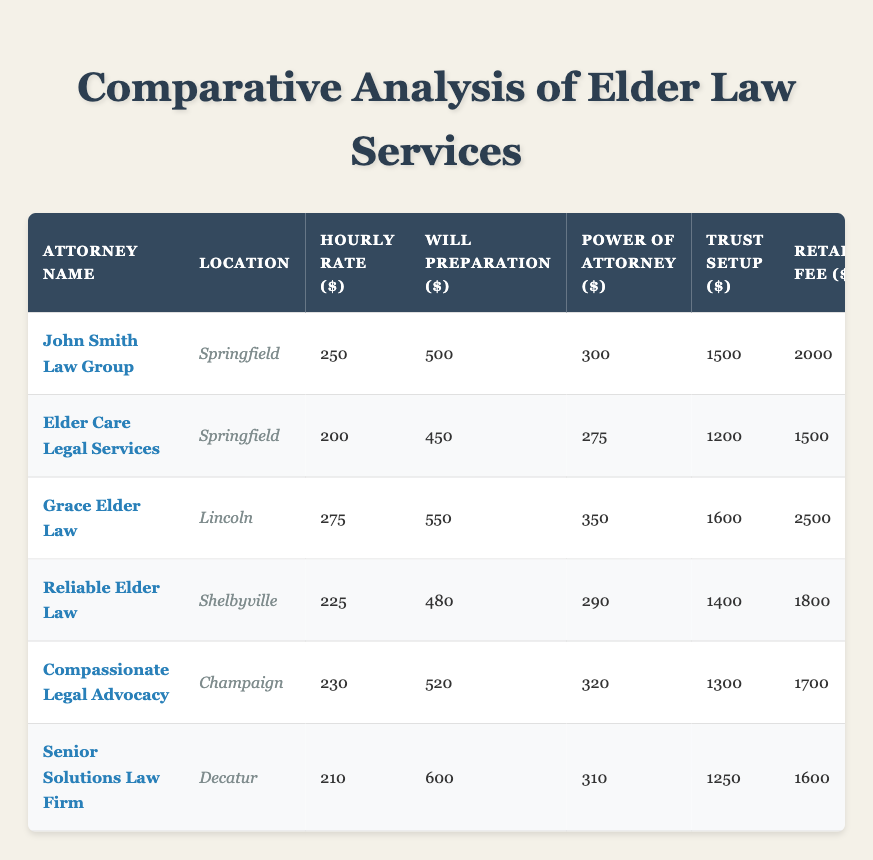What is the highest hourly rate among the attorneys listed? The highest hourly rate is found in the "Hourly Rate ($)" column. Scanning through the rates, John Smith Law Group has the highest rate at $250.
Answer: 250 Which attorney has the lowest consultation fee? The consultation fees can be found in the "Consultation Fee ($)" column. Looking at the values, Senior Solutions Law Firm has the lowest consultation fee at $110.
Answer: 110 How many years of experience does Grace Elder Law have? The years of experience for each attorney are listed in the "Experience (Years)" column. Grace Elder Law has 30 years of experience.
Answer: 30 What is the average flat fee for will preparation among all attorneys? To calculate the average, sum all the flat fee values for will preparation (500 + 450 + 550 + 480 + 520 + 600 = 3080) and divide by the number of attorneys (6), resulting in an average of 3080 / 6 = 513.33.
Answer: 513.33 Is the retainer fee for Compassionate Legal Advocacy higher than that of Elder Care Legal Services? Looking at the "Retainer Fee ($)" column, Compassionate Legal Advocacy has a retainer fee of $1700, and Elder Care Legal Services has $1500. Since $1700 is greater than $1500, the answer is yes.
Answer: Yes What is the difference in the flat fee for trust setup between the highest and lowest values? The highest flat fee for trust setup is Grace Elder Law at $1600, and the lowest is Senior Solutions Law Firm at $1250. The difference is 1600 - 1250 = 350.
Answer: 350 Which attorney has the best client rating and what is their rating? The client ratings are in the "Client Rating" column. Scanning through the ratings, Grace Elder Law has the highest rating at 4.9.
Answer: 4.9 What is the total retainer fee for all attorneys listed? To find the total retainer fee, sum all retainer fee values (2000 + 1500 + 2500 + 1800 + 1700 + 1600 = 12100). The total retainer fee is $12100.
Answer: 12100 Is there any attorney with fewer than 15 years of experience? By checking the "Experience (Years)" column, Senior Solutions Law Firm has only 12 years of experience, which is less than 15. Therefore, yes, there is an attorney with fewer than 15 years of experience.
Answer: Yes Which attorney has the second-highest flat fee for power of attorney? The flat fees for power of attorney are 300, 275, 350, 290, 320, and 310. Arranging them in descending order, the second-highest fee is 320 from Compassionate Legal Advocacy.
Answer: 320 What is the average rating of all the attorneys? To find the average rating, sum all the client ratings (4.8 + 4.5 + 4.9 + 4.3 + 4.6 + 4.0 = 27.1) and divide by the number of attorneys (6), resulting in an average rating of 27.1 / 6 = 4.52.
Answer: 4.52 